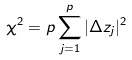Convert formula to latex. <formula><loc_0><loc_0><loc_500><loc_500>\chi ^ { 2 } = p \sum _ { j = 1 } ^ { p } | \Delta z _ { j } | ^ { 2 }</formula> 